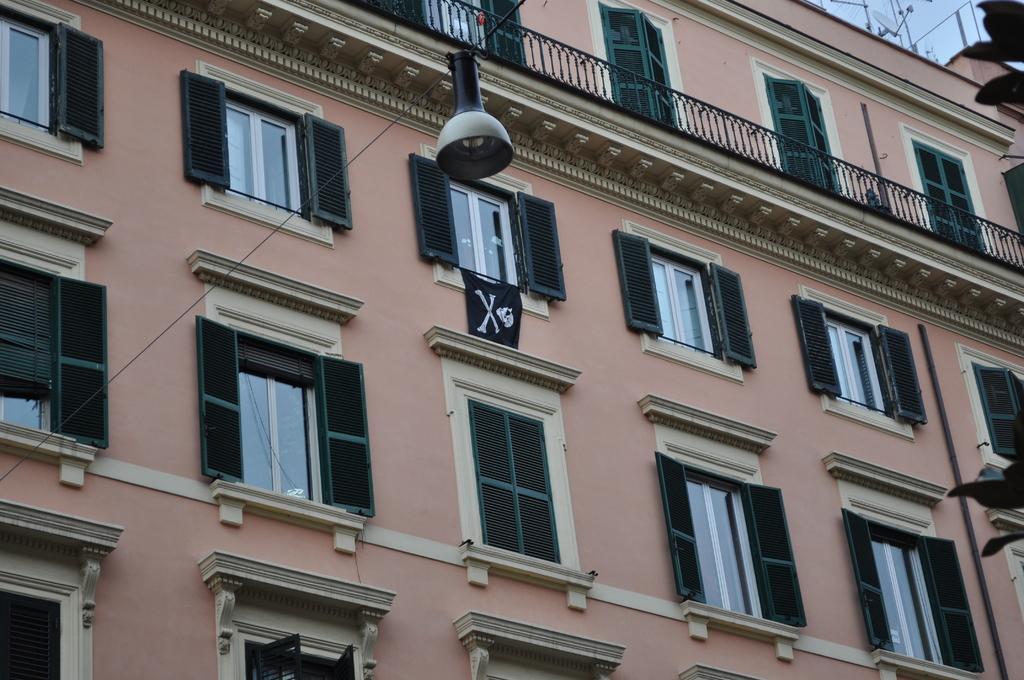Can you describe this image briefly? In this picture we can see building, there are so many windows to the wall and there is a light to the rope. 